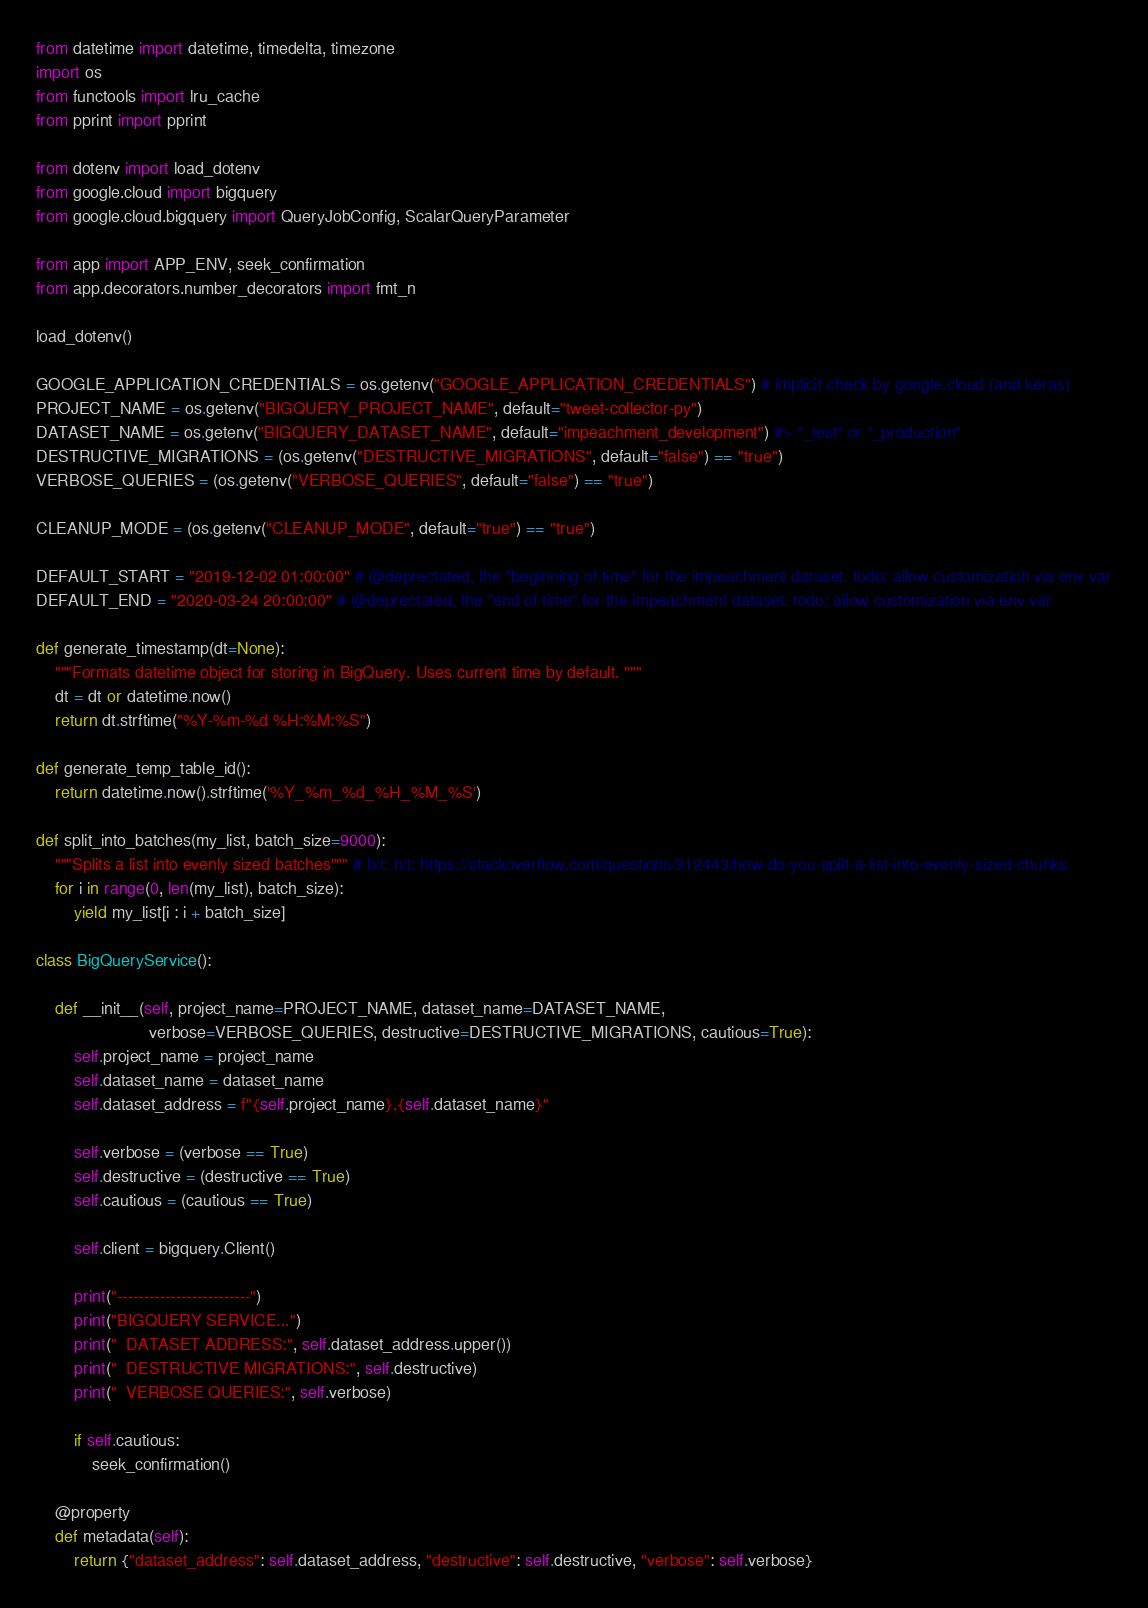<code> <loc_0><loc_0><loc_500><loc_500><_Python_>from datetime import datetime, timedelta, timezone
import os
from functools import lru_cache
from pprint import pprint

from dotenv import load_dotenv
from google.cloud import bigquery
from google.cloud.bigquery import QueryJobConfig, ScalarQueryParameter

from app import APP_ENV, seek_confirmation
from app.decorators.number_decorators import fmt_n

load_dotenv()

GOOGLE_APPLICATION_CREDENTIALS = os.getenv("GOOGLE_APPLICATION_CREDENTIALS") # implicit check by google.cloud (and keras)
PROJECT_NAME = os.getenv("BIGQUERY_PROJECT_NAME", default="tweet-collector-py")
DATASET_NAME = os.getenv("BIGQUERY_DATASET_NAME", default="impeachment_development") #> "_test" or "_production"
DESTRUCTIVE_MIGRATIONS = (os.getenv("DESTRUCTIVE_MIGRATIONS", default="false") == "true")
VERBOSE_QUERIES = (os.getenv("VERBOSE_QUERIES", default="false") == "true")

CLEANUP_MODE = (os.getenv("CLEANUP_MODE", default="true") == "true")

DEFAULT_START = "2019-12-02 01:00:00" # @deprectated, the "beginning of time" for the impeachment dataset. todo: allow customization via env var
DEFAULT_END = "2020-03-24 20:00:00" # @deprectated, the "end of time" for the impeachment dataset. todo: allow customization via env var

def generate_timestamp(dt=None):
    """Formats datetime object for storing in BigQuery. Uses current time by default. """
    dt = dt or datetime.now()
    return dt.strftime("%Y-%m-%d %H:%M:%S")

def generate_temp_table_id():
    return datetime.now().strftime('%Y_%m_%d_%H_%M_%S')

def split_into_batches(my_list, batch_size=9000):
    """Splits a list into evenly sized batches""" # h/t: h/t: https://stackoverflow.com/questions/312443/how-do-you-split-a-list-into-evenly-sized-chunks
    for i in range(0, len(my_list), batch_size):
        yield my_list[i : i + batch_size]

class BigQueryService():

    def __init__(self, project_name=PROJECT_NAME, dataset_name=DATASET_NAME,
                        verbose=VERBOSE_QUERIES, destructive=DESTRUCTIVE_MIGRATIONS, cautious=True):
        self.project_name = project_name
        self.dataset_name = dataset_name
        self.dataset_address = f"{self.project_name}.{self.dataset_name}"

        self.verbose = (verbose == True)
        self.destructive = (destructive == True)
        self.cautious = (cautious == True)

        self.client = bigquery.Client()

        print("-------------------------")
        print("BIGQUERY SERVICE...")
        print("  DATASET ADDRESS:", self.dataset_address.upper())
        print("  DESTRUCTIVE MIGRATIONS:", self.destructive)
        print("  VERBOSE QUERIES:", self.verbose)

        if self.cautious:
            seek_confirmation()

    @property
    def metadata(self):
        return {"dataset_address": self.dataset_address, "destructive": self.destructive, "verbose": self.verbose}
</code> 